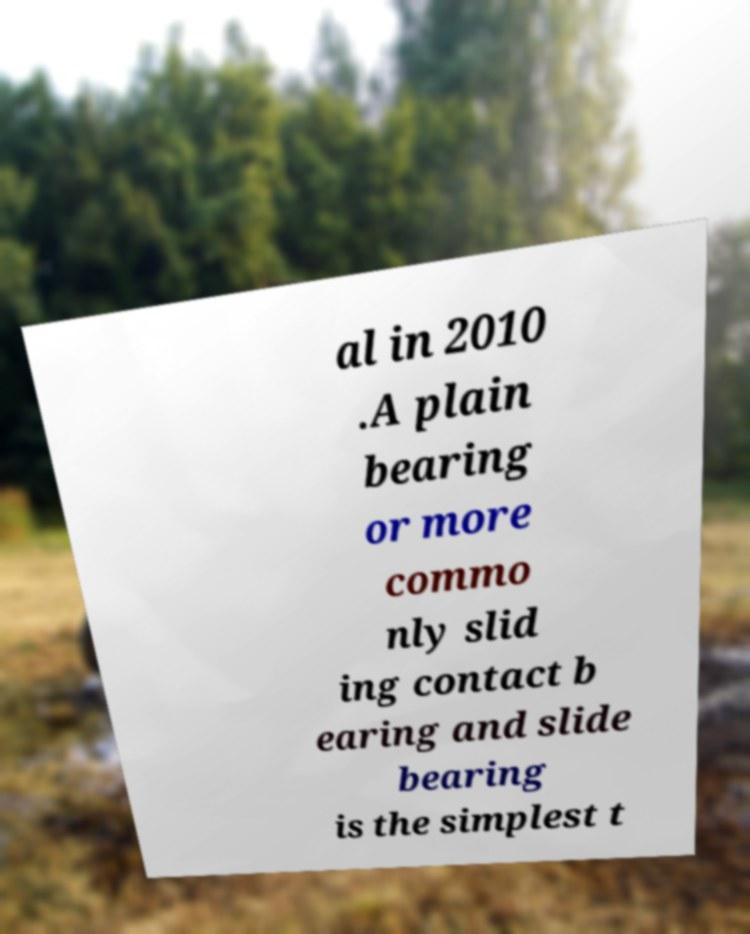Could you assist in decoding the text presented in this image and type it out clearly? al in 2010 .A plain bearing or more commo nly slid ing contact b earing and slide bearing is the simplest t 